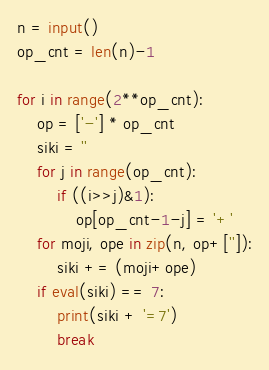Convert code to text. <code><loc_0><loc_0><loc_500><loc_500><_Python_>n = input()
op_cnt = len(n)-1

for i in range(2**op_cnt):
    op = ['-'] * op_cnt
    siki = ''
    for j in range(op_cnt):
        if ((i>>j)&1):
            op[op_cnt-1-j] = '+'
    for moji, ope in zip(n, op+['']):
        siki += (moji+ope)
    if eval(siki) == 7:
        print(siki + '=7')
        break
</code> 